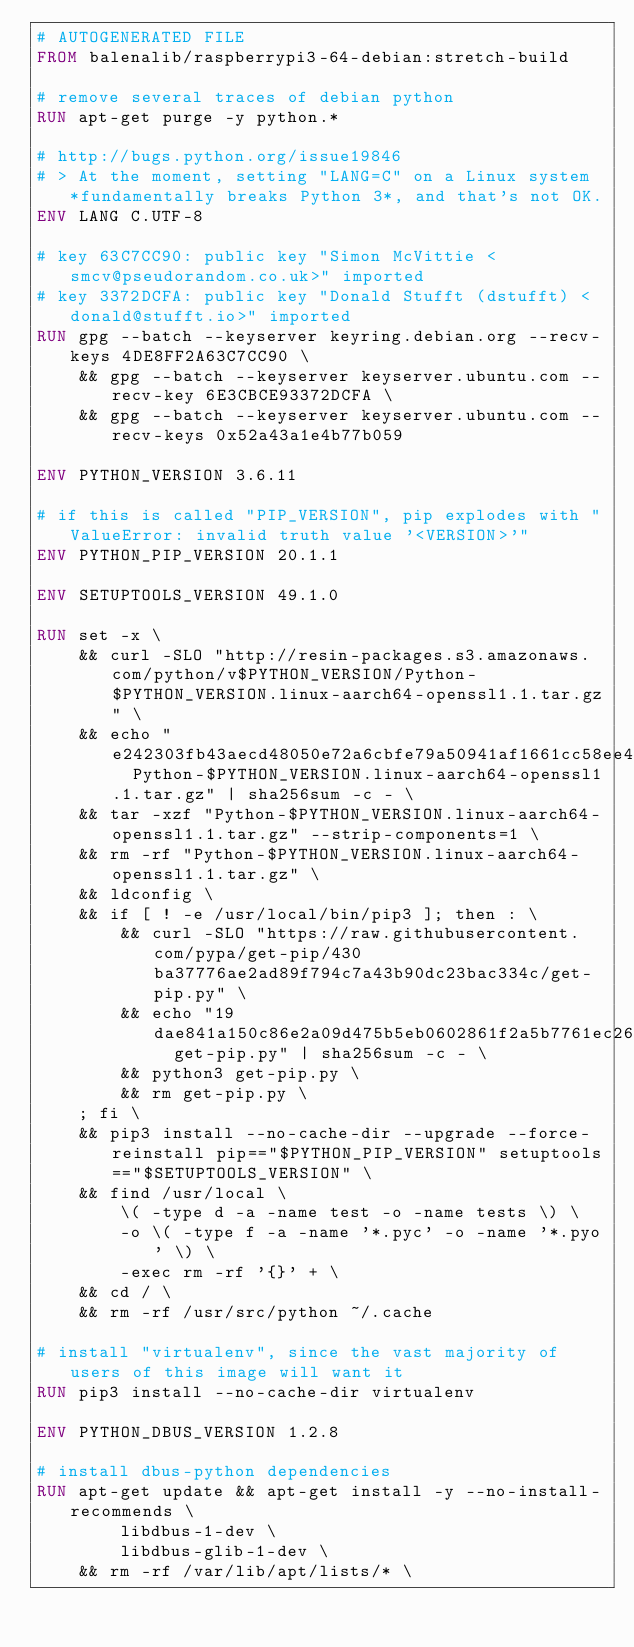Convert code to text. <code><loc_0><loc_0><loc_500><loc_500><_Dockerfile_># AUTOGENERATED FILE
FROM balenalib/raspberrypi3-64-debian:stretch-build

# remove several traces of debian python
RUN apt-get purge -y python.*

# http://bugs.python.org/issue19846
# > At the moment, setting "LANG=C" on a Linux system *fundamentally breaks Python 3*, and that's not OK.
ENV LANG C.UTF-8

# key 63C7CC90: public key "Simon McVittie <smcv@pseudorandom.co.uk>" imported
# key 3372DCFA: public key "Donald Stufft (dstufft) <donald@stufft.io>" imported
RUN gpg --batch --keyserver keyring.debian.org --recv-keys 4DE8FF2A63C7CC90 \
	&& gpg --batch --keyserver keyserver.ubuntu.com --recv-key 6E3CBCE93372DCFA \
	&& gpg --batch --keyserver keyserver.ubuntu.com --recv-keys 0x52a43a1e4b77b059

ENV PYTHON_VERSION 3.6.11

# if this is called "PIP_VERSION", pip explodes with "ValueError: invalid truth value '<VERSION>'"
ENV PYTHON_PIP_VERSION 20.1.1

ENV SETUPTOOLS_VERSION 49.1.0

RUN set -x \
	&& curl -SLO "http://resin-packages.s3.amazonaws.com/python/v$PYTHON_VERSION/Python-$PYTHON_VERSION.linux-aarch64-openssl1.1.tar.gz" \
	&& echo "e242303fb43aecd48050e72a6cbfe79a50941af1661cc58ee4db040046f82936  Python-$PYTHON_VERSION.linux-aarch64-openssl1.1.tar.gz" | sha256sum -c - \
	&& tar -xzf "Python-$PYTHON_VERSION.linux-aarch64-openssl1.1.tar.gz" --strip-components=1 \
	&& rm -rf "Python-$PYTHON_VERSION.linux-aarch64-openssl1.1.tar.gz" \
	&& ldconfig \
	&& if [ ! -e /usr/local/bin/pip3 ]; then : \
		&& curl -SLO "https://raw.githubusercontent.com/pypa/get-pip/430ba37776ae2ad89f794c7a43b90dc23bac334c/get-pip.py" \
		&& echo "19dae841a150c86e2a09d475b5eb0602861f2a5b7761ec268049a662dbd2bd0c  get-pip.py" | sha256sum -c - \
		&& python3 get-pip.py \
		&& rm get-pip.py \
	; fi \
	&& pip3 install --no-cache-dir --upgrade --force-reinstall pip=="$PYTHON_PIP_VERSION" setuptools=="$SETUPTOOLS_VERSION" \
	&& find /usr/local \
		\( -type d -a -name test -o -name tests \) \
		-o \( -type f -a -name '*.pyc' -o -name '*.pyo' \) \
		-exec rm -rf '{}' + \
	&& cd / \
	&& rm -rf /usr/src/python ~/.cache

# install "virtualenv", since the vast majority of users of this image will want it
RUN pip3 install --no-cache-dir virtualenv

ENV PYTHON_DBUS_VERSION 1.2.8

# install dbus-python dependencies 
RUN apt-get update && apt-get install -y --no-install-recommends \
		libdbus-1-dev \
		libdbus-glib-1-dev \
	&& rm -rf /var/lib/apt/lists/* \</code> 